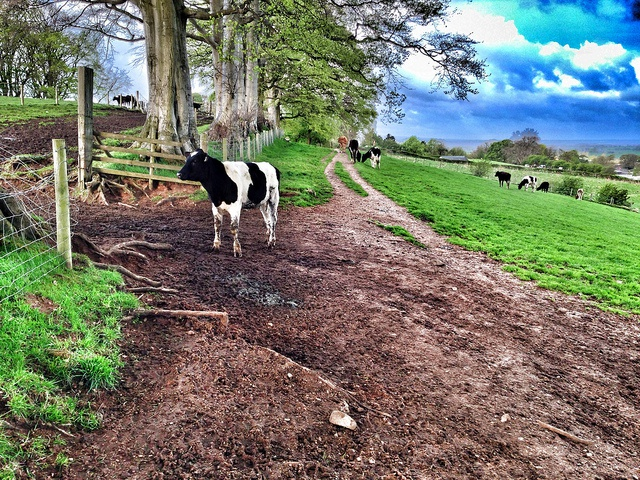Describe the objects in this image and their specific colors. I can see cow in gray, black, white, and darkgray tones, cow in gray, black, darkgray, and lightgray tones, cow in gray, black, ivory, and darkgray tones, cow in gray, black, darkgray, and darkgreen tones, and cow in gray, brown, tan, and maroon tones in this image. 